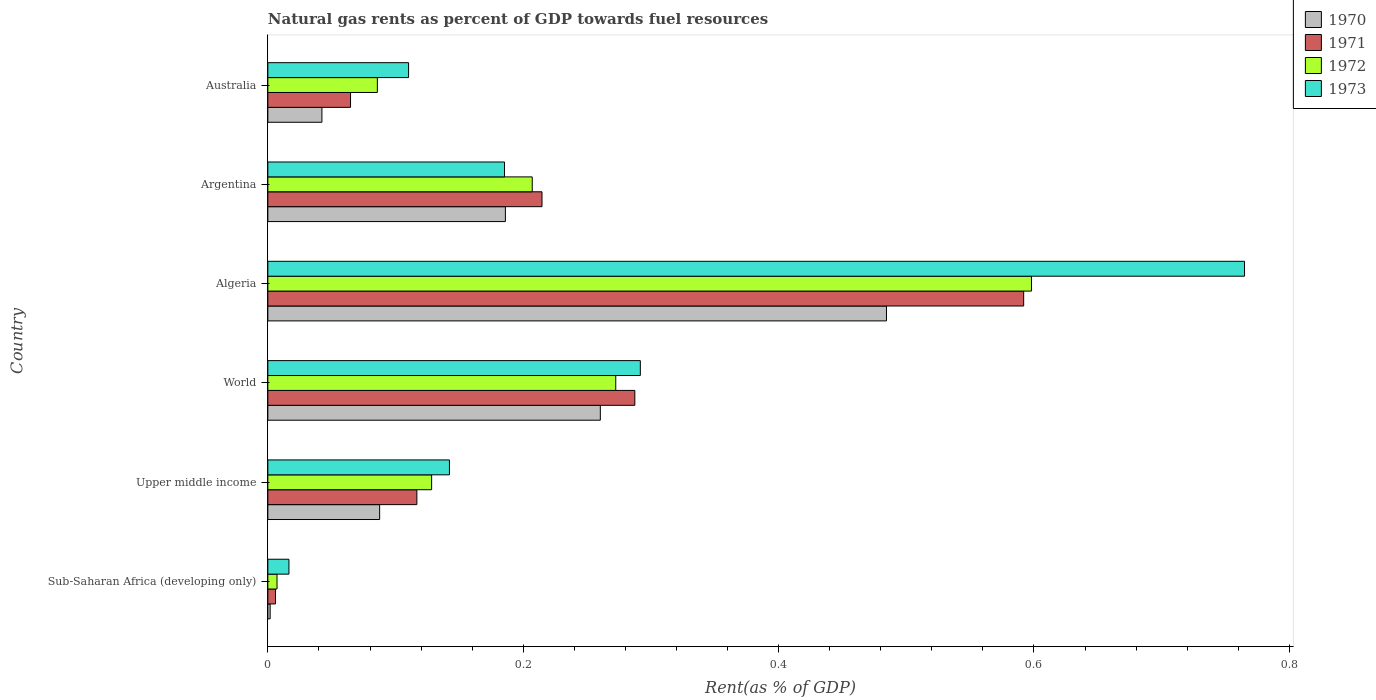How many different coloured bars are there?
Your response must be concise. 4. How many groups of bars are there?
Provide a succinct answer. 6. Are the number of bars per tick equal to the number of legend labels?
Offer a terse response. Yes. What is the label of the 1st group of bars from the top?
Offer a very short reply. Australia. In how many cases, is the number of bars for a given country not equal to the number of legend labels?
Ensure brevity in your answer.  0. What is the matural gas rent in 1973 in World?
Your answer should be compact. 0.29. Across all countries, what is the maximum matural gas rent in 1970?
Ensure brevity in your answer.  0.48. Across all countries, what is the minimum matural gas rent in 1971?
Ensure brevity in your answer.  0.01. In which country was the matural gas rent in 1972 maximum?
Offer a very short reply. Algeria. In which country was the matural gas rent in 1972 minimum?
Offer a terse response. Sub-Saharan Africa (developing only). What is the total matural gas rent in 1973 in the graph?
Your answer should be very brief. 1.51. What is the difference between the matural gas rent in 1973 in Algeria and that in Argentina?
Your answer should be compact. 0.58. What is the difference between the matural gas rent in 1972 in Australia and the matural gas rent in 1970 in Upper middle income?
Offer a very short reply. -0. What is the average matural gas rent in 1972 per country?
Keep it short and to the point. 0.22. What is the difference between the matural gas rent in 1972 and matural gas rent in 1971 in Argentina?
Your response must be concise. -0.01. In how many countries, is the matural gas rent in 1973 greater than 0.4 %?
Your response must be concise. 1. What is the ratio of the matural gas rent in 1970 in Australia to that in Upper middle income?
Your response must be concise. 0.48. Is the matural gas rent in 1973 in Algeria less than that in Australia?
Offer a terse response. No. What is the difference between the highest and the second highest matural gas rent in 1971?
Your answer should be very brief. 0.3. What is the difference between the highest and the lowest matural gas rent in 1970?
Ensure brevity in your answer.  0.48. Is the sum of the matural gas rent in 1970 in Algeria and Upper middle income greater than the maximum matural gas rent in 1971 across all countries?
Give a very brief answer. No. What does the 3rd bar from the bottom in Upper middle income represents?
Your answer should be compact. 1972. Is it the case that in every country, the sum of the matural gas rent in 1970 and matural gas rent in 1971 is greater than the matural gas rent in 1972?
Provide a short and direct response. Yes. Are all the bars in the graph horizontal?
Provide a succinct answer. Yes. How many countries are there in the graph?
Your answer should be compact. 6. Are the values on the major ticks of X-axis written in scientific E-notation?
Your response must be concise. No. Does the graph contain any zero values?
Provide a short and direct response. No. Does the graph contain grids?
Your response must be concise. No. Where does the legend appear in the graph?
Make the answer very short. Top right. How many legend labels are there?
Make the answer very short. 4. What is the title of the graph?
Make the answer very short. Natural gas rents as percent of GDP towards fuel resources. Does "1965" appear as one of the legend labels in the graph?
Your response must be concise. No. What is the label or title of the X-axis?
Offer a terse response. Rent(as % of GDP). What is the label or title of the Y-axis?
Offer a very short reply. Country. What is the Rent(as % of GDP) in 1970 in Sub-Saharan Africa (developing only)?
Make the answer very short. 0. What is the Rent(as % of GDP) in 1971 in Sub-Saharan Africa (developing only)?
Your answer should be very brief. 0.01. What is the Rent(as % of GDP) in 1972 in Sub-Saharan Africa (developing only)?
Offer a very short reply. 0.01. What is the Rent(as % of GDP) in 1973 in Sub-Saharan Africa (developing only)?
Keep it short and to the point. 0.02. What is the Rent(as % of GDP) in 1970 in Upper middle income?
Your response must be concise. 0.09. What is the Rent(as % of GDP) in 1971 in Upper middle income?
Provide a succinct answer. 0.12. What is the Rent(as % of GDP) of 1972 in Upper middle income?
Make the answer very short. 0.13. What is the Rent(as % of GDP) of 1973 in Upper middle income?
Give a very brief answer. 0.14. What is the Rent(as % of GDP) of 1970 in World?
Provide a succinct answer. 0.26. What is the Rent(as % of GDP) in 1971 in World?
Provide a succinct answer. 0.29. What is the Rent(as % of GDP) of 1972 in World?
Provide a succinct answer. 0.27. What is the Rent(as % of GDP) in 1973 in World?
Keep it short and to the point. 0.29. What is the Rent(as % of GDP) of 1970 in Algeria?
Keep it short and to the point. 0.48. What is the Rent(as % of GDP) in 1971 in Algeria?
Your answer should be very brief. 0.59. What is the Rent(as % of GDP) of 1972 in Algeria?
Provide a succinct answer. 0.6. What is the Rent(as % of GDP) of 1973 in Algeria?
Provide a short and direct response. 0.76. What is the Rent(as % of GDP) of 1970 in Argentina?
Offer a terse response. 0.19. What is the Rent(as % of GDP) of 1971 in Argentina?
Offer a very short reply. 0.21. What is the Rent(as % of GDP) in 1972 in Argentina?
Offer a terse response. 0.21. What is the Rent(as % of GDP) of 1973 in Argentina?
Offer a very short reply. 0.19. What is the Rent(as % of GDP) in 1970 in Australia?
Your answer should be compact. 0.04. What is the Rent(as % of GDP) in 1971 in Australia?
Make the answer very short. 0.06. What is the Rent(as % of GDP) in 1972 in Australia?
Offer a very short reply. 0.09. What is the Rent(as % of GDP) in 1973 in Australia?
Provide a succinct answer. 0.11. Across all countries, what is the maximum Rent(as % of GDP) in 1970?
Give a very brief answer. 0.48. Across all countries, what is the maximum Rent(as % of GDP) of 1971?
Provide a succinct answer. 0.59. Across all countries, what is the maximum Rent(as % of GDP) of 1972?
Your response must be concise. 0.6. Across all countries, what is the maximum Rent(as % of GDP) of 1973?
Your answer should be very brief. 0.76. Across all countries, what is the minimum Rent(as % of GDP) in 1970?
Ensure brevity in your answer.  0. Across all countries, what is the minimum Rent(as % of GDP) of 1971?
Keep it short and to the point. 0.01. Across all countries, what is the minimum Rent(as % of GDP) of 1972?
Offer a very short reply. 0.01. Across all countries, what is the minimum Rent(as % of GDP) of 1973?
Your response must be concise. 0.02. What is the total Rent(as % of GDP) in 1970 in the graph?
Your response must be concise. 1.06. What is the total Rent(as % of GDP) of 1971 in the graph?
Make the answer very short. 1.28. What is the total Rent(as % of GDP) in 1972 in the graph?
Offer a very short reply. 1.3. What is the total Rent(as % of GDP) in 1973 in the graph?
Your answer should be compact. 1.51. What is the difference between the Rent(as % of GDP) in 1970 in Sub-Saharan Africa (developing only) and that in Upper middle income?
Provide a succinct answer. -0.09. What is the difference between the Rent(as % of GDP) in 1971 in Sub-Saharan Africa (developing only) and that in Upper middle income?
Provide a succinct answer. -0.11. What is the difference between the Rent(as % of GDP) in 1972 in Sub-Saharan Africa (developing only) and that in Upper middle income?
Provide a succinct answer. -0.12. What is the difference between the Rent(as % of GDP) in 1973 in Sub-Saharan Africa (developing only) and that in Upper middle income?
Provide a succinct answer. -0.13. What is the difference between the Rent(as % of GDP) in 1970 in Sub-Saharan Africa (developing only) and that in World?
Make the answer very short. -0.26. What is the difference between the Rent(as % of GDP) of 1971 in Sub-Saharan Africa (developing only) and that in World?
Your answer should be very brief. -0.28. What is the difference between the Rent(as % of GDP) in 1972 in Sub-Saharan Africa (developing only) and that in World?
Your answer should be compact. -0.27. What is the difference between the Rent(as % of GDP) of 1973 in Sub-Saharan Africa (developing only) and that in World?
Ensure brevity in your answer.  -0.28. What is the difference between the Rent(as % of GDP) in 1970 in Sub-Saharan Africa (developing only) and that in Algeria?
Provide a succinct answer. -0.48. What is the difference between the Rent(as % of GDP) of 1971 in Sub-Saharan Africa (developing only) and that in Algeria?
Offer a very short reply. -0.59. What is the difference between the Rent(as % of GDP) of 1972 in Sub-Saharan Africa (developing only) and that in Algeria?
Your answer should be very brief. -0.59. What is the difference between the Rent(as % of GDP) of 1973 in Sub-Saharan Africa (developing only) and that in Algeria?
Your response must be concise. -0.75. What is the difference between the Rent(as % of GDP) in 1970 in Sub-Saharan Africa (developing only) and that in Argentina?
Give a very brief answer. -0.18. What is the difference between the Rent(as % of GDP) of 1971 in Sub-Saharan Africa (developing only) and that in Argentina?
Offer a terse response. -0.21. What is the difference between the Rent(as % of GDP) of 1972 in Sub-Saharan Africa (developing only) and that in Argentina?
Your answer should be compact. -0.2. What is the difference between the Rent(as % of GDP) of 1973 in Sub-Saharan Africa (developing only) and that in Argentina?
Your answer should be compact. -0.17. What is the difference between the Rent(as % of GDP) in 1970 in Sub-Saharan Africa (developing only) and that in Australia?
Offer a very short reply. -0.04. What is the difference between the Rent(as % of GDP) in 1971 in Sub-Saharan Africa (developing only) and that in Australia?
Ensure brevity in your answer.  -0.06. What is the difference between the Rent(as % of GDP) of 1972 in Sub-Saharan Africa (developing only) and that in Australia?
Your answer should be very brief. -0.08. What is the difference between the Rent(as % of GDP) of 1973 in Sub-Saharan Africa (developing only) and that in Australia?
Keep it short and to the point. -0.09. What is the difference between the Rent(as % of GDP) in 1970 in Upper middle income and that in World?
Provide a short and direct response. -0.17. What is the difference between the Rent(as % of GDP) in 1971 in Upper middle income and that in World?
Provide a short and direct response. -0.17. What is the difference between the Rent(as % of GDP) of 1972 in Upper middle income and that in World?
Keep it short and to the point. -0.14. What is the difference between the Rent(as % of GDP) in 1973 in Upper middle income and that in World?
Your answer should be very brief. -0.15. What is the difference between the Rent(as % of GDP) of 1970 in Upper middle income and that in Algeria?
Ensure brevity in your answer.  -0.4. What is the difference between the Rent(as % of GDP) in 1971 in Upper middle income and that in Algeria?
Offer a terse response. -0.48. What is the difference between the Rent(as % of GDP) of 1972 in Upper middle income and that in Algeria?
Offer a very short reply. -0.47. What is the difference between the Rent(as % of GDP) of 1973 in Upper middle income and that in Algeria?
Keep it short and to the point. -0.62. What is the difference between the Rent(as % of GDP) in 1970 in Upper middle income and that in Argentina?
Ensure brevity in your answer.  -0.1. What is the difference between the Rent(as % of GDP) of 1971 in Upper middle income and that in Argentina?
Keep it short and to the point. -0.1. What is the difference between the Rent(as % of GDP) in 1972 in Upper middle income and that in Argentina?
Your answer should be compact. -0.08. What is the difference between the Rent(as % of GDP) of 1973 in Upper middle income and that in Argentina?
Your answer should be very brief. -0.04. What is the difference between the Rent(as % of GDP) of 1970 in Upper middle income and that in Australia?
Provide a short and direct response. 0.05. What is the difference between the Rent(as % of GDP) of 1971 in Upper middle income and that in Australia?
Offer a very short reply. 0.05. What is the difference between the Rent(as % of GDP) in 1972 in Upper middle income and that in Australia?
Give a very brief answer. 0.04. What is the difference between the Rent(as % of GDP) of 1973 in Upper middle income and that in Australia?
Your answer should be very brief. 0.03. What is the difference between the Rent(as % of GDP) of 1970 in World and that in Algeria?
Provide a succinct answer. -0.22. What is the difference between the Rent(as % of GDP) in 1971 in World and that in Algeria?
Your response must be concise. -0.3. What is the difference between the Rent(as % of GDP) in 1972 in World and that in Algeria?
Keep it short and to the point. -0.33. What is the difference between the Rent(as % of GDP) of 1973 in World and that in Algeria?
Offer a terse response. -0.47. What is the difference between the Rent(as % of GDP) in 1970 in World and that in Argentina?
Your response must be concise. 0.07. What is the difference between the Rent(as % of GDP) in 1971 in World and that in Argentina?
Your answer should be very brief. 0.07. What is the difference between the Rent(as % of GDP) of 1972 in World and that in Argentina?
Offer a very short reply. 0.07. What is the difference between the Rent(as % of GDP) of 1973 in World and that in Argentina?
Your response must be concise. 0.11. What is the difference between the Rent(as % of GDP) of 1970 in World and that in Australia?
Offer a very short reply. 0.22. What is the difference between the Rent(as % of GDP) in 1971 in World and that in Australia?
Provide a succinct answer. 0.22. What is the difference between the Rent(as % of GDP) of 1972 in World and that in Australia?
Your answer should be compact. 0.19. What is the difference between the Rent(as % of GDP) of 1973 in World and that in Australia?
Offer a very short reply. 0.18. What is the difference between the Rent(as % of GDP) of 1970 in Algeria and that in Argentina?
Your answer should be very brief. 0.3. What is the difference between the Rent(as % of GDP) of 1971 in Algeria and that in Argentina?
Keep it short and to the point. 0.38. What is the difference between the Rent(as % of GDP) of 1972 in Algeria and that in Argentina?
Offer a very short reply. 0.39. What is the difference between the Rent(as % of GDP) in 1973 in Algeria and that in Argentina?
Make the answer very short. 0.58. What is the difference between the Rent(as % of GDP) in 1970 in Algeria and that in Australia?
Ensure brevity in your answer.  0.44. What is the difference between the Rent(as % of GDP) of 1971 in Algeria and that in Australia?
Your answer should be compact. 0.53. What is the difference between the Rent(as % of GDP) in 1972 in Algeria and that in Australia?
Provide a short and direct response. 0.51. What is the difference between the Rent(as % of GDP) in 1973 in Algeria and that in Australia?
Provide a succinct answer. 0.65. What is the difference between the Rent(as % of GDP) in 1970 in Argentina and that in Australia?
Offer a terse response. 0.14. What is the difference between the Rent(as % of GDP) in 1971 in Argentina and that in Australia?
Your answer should be compact. 0.15. What is the difference between the Rent(as % of GDP) of 1972 in Argentina and that in Australia?
Keep it short and to the point. 0.12. What is the difference between the Rent(as % of GDP) of 1973 in Argentina and that in Australia?
Keep it short and to the point. 0.08. What is the difference between the Rent(as % of GDP) of 1970 in Sub-Saharan Africa (developing only) and the Rent(as % of GDP) of 1971 in Upper middle income?
Provide a short and direct response. -0.11. What is the difference between the Rent(as % of GDP) in 1970 in Sub-Saharan Africa (developing only) and the Rent(as % of GDP) in 1972 in Upper middle income?
Give a very brief answer. -0.13. What is the difference between the Rent(as % of GDP) in 1970 in Sub-Saharan Africa (developing only) and the Rent(as % of GDP) in 1973 in Upper middle income?
Keep it short and to the point. -0.14. What is the difference between the Rent(as % of GDP) of 1971 in Sub-Saharan Africa (developing only) and the Rent(as % of GDP) of 1972 in Upper middle income?
Ensure brevity in your answer.  -0.12. What is the difference between the Rent(as % of GDP) in 1971 in Sub-Saharan Africa (developing only) and the Rent(as % of GDP) in 1973 in Upper middle income?
Offer a terse response. -0.14. What is the difference between the Rent(as % of GDP) in 1972 in Sub-Saharan Africa (developing only) and the Rent(as % of GDP) in 1973 in Upper middle income?
Ensure brevity in your answer.  -0.14. What is the difference between the Rent(as % of GDP) in 1970 in Sub-Saharan Africa (developing only) and the Rent(as % of GDP) in 1971 in World?
Your answer should be very brief. -0.29. What is the difference between the Rent(as % of GDP) in 1970 in Sub-Saharan Africa (developing only) and the Rent(as % of GDP) in 1972 in World?
Keep it short and to the point. -0.27. What is the difference between the Rent(as % of GDP) of 1970 in Sub-Saharan Africa (developing only) and the Rent(as % of GDP) of 1973 in World?
Ensure brevity in your answer.  -0.29. What is the difference between the Rent(as % of GDP) in 1971 in Sub-Saharan Africa (developing only) and the Rent(as % of GDP) in 1972 in World?
Your response must be concise. -0.27. What is the difference between the Rent(as % of GDP) in 1971 in Sub-Saharan Africa (developing only) and the Rent(as % of GDP) in 1973 in World?
Provide a short and direct response. -0.29. What is the difference between the Rent(as % of GDP) in 1972 in Sub-Saharan Africa (developing only) and the Rent(as % of GDP) in 1973 in World?
Offer a very short reply. -0.28. What is the difference between the Rent(as % of GDP) in 1970 in Sub-Saharan Africa (developing only) and the Rent(as % of GDP) in 1971 in Algeria?
Provide a short and direct response. -0.59. What is the difference between the Rent(as % of GDP) in 1970 in Sub-Saharan Africa (developing only) and the Rent(as % of GDP) in 1972 in Algeria?
Your response must be concise. -0.6. What is the difference between the Rent(as % of GDP) in 1970 in Sub-Saharan Africa (developing only) and the Rent(as % of GDP) in 1973 in Algeria?
Make the answer very short. -0.76. What is the difference between the Rent(as % of GDP) in 1971 in Sub-Saharan Africa (developing only) and the Rent(as % of GDP) in 1972 in Algeria?
Offer a very short reply. -0.59. What is the difference between the Rent(as % of GDP) of 1971 in Sub-Saharan Africa (developing only) and the Rent(as % of GDP) of 1973 in Algeria?
Keep it short and to the point. -0.76. What is the difference between the Rent(as % of GDP) in 1972 in Sub-Saharan Africa (developing only) and the Rent(as % of GDP) in 1973 in Algeria?
Ensure brevity in your answer.  -0.76. What is the difference between the Rent(as % of GDP) of 1970 in Sub-Saharan Africa (developing only) and the Rent(as % of GDP) of 1971 in Argentina?
Keep it short and to the point. -0.21. What is the difference between the Rent(as % of GDP) in 1970 in Sub-Saharan Africa (developing only) and the Rent(as % of GDP) in 1972 in Argentina?
Keep it short and to the point. -0.21. What is the difference between the Rent(as % of GDP) of 1970 in Sub-Saharan Africa (developing only) and the Rent(as % of GDP) of 1973 in Argentina?
Your answer should be very brief. -0.18. What is the difference between the Rent(as % of GDP) of 1971 in Sub-Saharan Africa (developing only) and the Rent(as % of GDP) of 1972 in Argentina?
Ensure brevity in your answer.  -0.2. What is the difference between the Rent(as % of GDP) of 1971 in Sub-Saharan Africa (developing only) and the Rent(as % of GDP) of 1973 in Argentina?
Provide a short and direct response. -0.18. What is the difference between the Rent(as % of GDP) of 1972 in Sub-Saharan Africa (developing only) and the Rent(as % of GDP) of 1973 in Argentina?
Your response must be concise. -0.18. What is the difference between the Rent(as % of GDP) of 1970 in Sub-Saharan Africa (developing only) and the Rent(as % of GDP) of 1971 in Australia?
Give a very brief answer. -0.06. What is the difference between the Rent(as % of GDP) in 1970 in Sub-Saharan Africa (developing only) and the Rent(as % of GDP) in 1972 in Australia?
Your answer should be compact. -0.08. What is the difference between the Rent(as % of GDP) in 1970 in Sub-Saharan Africa (developing only) and the Rent(as % of GDP) in 1973 in Australia?
Offer a terse response. -0.11. What is the difference between the Rent(as % of GDP) in 1971 in Sub-Saharan Africa (developing only) and the Rent(as % of GDP) in 1972 in Australia?
Your response must be concise. -0.08. What is the difference between the Rent(as % of GDP) in 1971 in Sub-Saharan Africa (developing only) and the Rent(as % of GDP) in 1973 in Australia?
Provide a succinct answer. -0.1. What is the difference between the Rent(as % of GDP) of 1972 in Sub-Saharan Africa (developing only) and the Rent(as % of GDP) of 1973 in Australia?
Give a very brief answer. -0.1. What is the difference between the Rent(as % of GDP) in 1970 in Upper middle income and the Rent(as % of GDP) in 1971 in World?
Your answer should be compact. -0.2. What is the difference between the Rent(as % of GDP) of 1970 in Upper middle income and the Rent(as % of GDP) of 1972 in World?
Give a very brief answer. -0.18. What is the difference between the Rent(as % of GDP) of 1970 in Upper middle income and the Rent(as % of GDP) of 1973 in World?
Keep it short and to the point. -0.2. What is the difference between the Rent(as % of GDP) of 1971 in Upper middle income and the Rent(as % of GDP) of 1972 in World?
Make the answer very short. -0.16. What is the difference between the Rent(as % of GDP) in 1971 in Upper middle income and the Rent(as % of GDP) in 1973 in World?
Keep it short and to the point. -0.17. What is the difference between the Rent(as % of GDP) in 1972 in Upper middle income and the Rent(as % of GDP) in 1973 in World?
Your answer should be compact. -0.16. What is the difference between the Rent(as % of GDP) of 1970 in Upper middle income and the Rent(as % of GDP) of 1971 in Algeria?
Offer a very short reply. -0.5. What is the difference between the Rent(as % of GDP) of 1970 in Upper middle income and the Rent(as % of GDP) of 1972 in Algeria?
Provide a succinct answer. -0.51. What is the difference between the Rent(as % of GDP) of 1970 in Upper middle income and the Rent(as % of GDP) of 1973 in Algeria?
Provide a short and direct response. -0.68. What is the difference between the Rent(as % of GDP) in 1971 in Upper middle income and the Rent(as % of GDP) in 1972 in Algeria?
Your answer should be compact. -0.48. What is the difference between the Rent(as % of GDP) in 1971 in Upper middle income and the Rent(as % of GDP) in 1973 in Algeria?
Provide a succinct answer. -0.65. What is the difference between the Rent(as % of GDP) in 1972 in Upper middle income and the Rent(as % of GDP) in 1973 in Algeria?
Keep it short and to the point. -0.64. What is the difference between the Rent(as % of GDP) in 1970 in Upper middle income and the Rent(as % of GDP) in 1971 in Argentina?
Your response must be concise. -0.13. What is the difference between the Rent(as % of GDP) of 1970 in Upper middle income and the Rent(as % of GDP) of 1972 in Argentina?
Provide a succinct answer. -0.12. What is the difference between the Rent(as % of GDP) in 1970 in Upper middle income and the Rent(as % of GDP) in 1973 in Argentina?
Provide a succinct answer. -0.1. What is the difference between the Rent(as % of GDP) of 1971 in Upper middle income and the Rent(as % of GDP) of 1972 in Argentina?
Your response must be concise. -0.09. What is the difference between the Rent(as % of GDP) in 1971 in Upper middle income and the Rent(as % of GDP) in 1973 in Argentina?
Provide a succinct answer. -0.07. What is the difference between the Rent(as % of GDP) in 1972 in Upper middle income and the Rent(as % of GDP) in 1973 in Argentina?
Offer a terse response. -0.06. What is the difference between the Rent(as % of GDP) of 1970 in Upper middle income and the Rent(as % of GDP) of 1971 in Australia?
Make the answer very short. 0.02. What is the difference between the Rent(as % of GDP) in 1970 in Upper middle income and the Rent(as % of GDP) in 1972 in Australia?
Ensure brevity in your answer.  0. What is the difference between the Rent(as % of GDP) of 1970 in Upper middle income and the Rent(as % of GDP) of 1973 in Australia?
Offer a terse response. -0.02. What is the difference between the Rent(as % of GDP) in 1971 in Upper middle income and the Rent(as % of GDP) in 1972 in Australia?
Your answer should be compact. 0.03. What is the difference between the Rent(as % of GDP) in 1971 in Upper middle income and the Rent(as % of GDP) in 1973 in Australia?
Provide a short and direct response. 0.01. What is the difference between the Rent(as % of GDP) of 1972 in Upper middle income and the Rent(as % of GDP) of 1973 in Australia?
Provide a short and direct response. 0.02. What is the difference between the Rent(as % of GDP) of 1970 in World and the Rent(as % of GDP) of 1971 in Algeria?
Provide a short and direct response. -0.33. What is the difference between the Rent(as % of GDP) of 1970 in World and the Rent(as % of GDP) of 1972 in Algeria?
Provide a short and direct response. -0.34. What is the difference between the Rent(as % of GDP) of 1970 in World and the Rent(as % of GDP) of 1973 in Algeria?
Your answer should be very brief. -0.5. What is the difference between the Rent(as % of GDP) of 1971 in World and the Rent(as % of GDP) of 1972 in Algeria?
Your answer should be compact. -0.31. What is the difference between the Rent(as % of GDP) of 1971 in World and the Rent(as % of GDP) of 1973 in Algeria?
Your response must be concise. -0.48. What is the difference between the Rent(as % of GDP) of 1972 in World and the Rent(as % of GDP) of 1973 in Algeria?
Provide a succinct answer. -0.49. What is the difference between the Rent(as % of GDP) in 1970 in World and the Rent(as % of GDP) in 1971 in Argentina?
Offer a terse response. 0.05. What is the difference between the Rent(as % of GDP) in 1970 in World and the Rent(as % of GDP) in 1972 in Argentina?
Provide a succinct answer. 0.05. What is the difference between the Rent(as % of GDP) in 1970 in World and the Rent(as % of GDP) in 1973 in Argentina?
Give a very brief answer. 0.07. What is the difference between the Rent(as % of GDP) in 1971 in World and the Rent(as % of GDP) in 1972 in Argentina?
Your answer should be compact. 0.08. What is the difference between the Rent(as % of GDP) in 1971 in World and the Rent(as % of GDP) in 1973 in Argentina?
Your answer should be very brief. 0.1. What is the difference between the Rent(as % of GDP) of 1972 in World and the Rent(as % of GDP) of 1973 in Argentina?
Your response must be concise. 0.09. What is the difference between the Rent(as % of GDP) in 1970 in World and the Rent(as % of GDP) in 1971 in Australia?
Offer a very short reply. 0.2. What is the difference between the Rent(as % of GDP) of 1970 in World and the Rent(as % of GDP) of 1972 in Australia?
Your response must be concise. 0.17. What is the difference between the Rent(as % of GDP) of 1970 in World and the Rent(as % of GDP) of 1973 in Australia?
Give a very brief answer. 0.15. What is the difference between the Rent(as % of GDP) of 1971 in World and the Rent(as % of GDP) of 1972 in Australia?
Your answer should be compact. 0.2. What is the difference between the Rent(as % of GDP) in 1971 in World and the Rent(as % of GDP) in 1973 in Australia?
Offer a terse response. 0.18. What is the difference between the Rent(as % of GDP) of 1972 in World and the Rent(as % of GDP) of 1973 in Australia?
Make the answer very short. 0.16. What is the difference between the Rent(as % of GDP) in 1970 in Algeria and the Rent(as % of GDP) in 1971 in Argentina?
Keep it short and to the point. 0.27. What is the difference between the Rent(as % of GDP) of 1970 in Algeria and the Rent(as % of GDP) of 1972 in Argentina?
Your answer should be compact. 0.28. What is the difference between the Rent(as % of GDP) of 1970 in Algeria and the Rent(as % of GDP) of 1973 in Argentina?
Your answer should be very brief. 0.3. What is the difference between the Rent(as % of GDP) in 1971 in Algeria and the Rent(as % of GDP) in 1972 in Argentina?
Keep it short and to the point. 0.38. What is the difference between the Rent(as % of GDP) in 1971 in Algeria and the Rent(as % of GDP) in 1973 in Argentina?
Keep it short and to the point. 0.41. What is the difference between the Rent(as % of GDP) in 1972 in Algeria and the Rent(as % of GDP) in 1973 in Argentina?
Your answer should be very brief. 0.41. What is the difference between the Rent(as % of GDP) of 1970 in Algeria and the Rent(as % of GDP) of 1971 in Australia?
Offer a very short reply. 0.42. What is the difference between the Rent(as % of GDP) of 1970 in Algeria and the Rent(as % of GDP) of 1972 in Australia?
Provide a succinct answer. 0.4. What is the difference between the Rent(as % of GDP) in 1970 in Algeria and the Rent(as % of GDP) in 1973 in Australia?
Your answer should be compact. 0.37. What is the difference between the Rent(as % of GDP) in 1971 in Algeria and the Rent(as % of GDP) in 1972 in Australia?
Keep it short and to the point. 0.51. What is the difference between the Rent(as % of GDP) in 1971 in Algeria and the Rent(as % of GDP) in 1973 in Australia?
Offer a terse response. 0.48. What is the difference between the Rent(as % of GDP) of 1972 in Algeria and the Rent(as % of GDP) of 1973 in Australia?
Offer a very short reply. 0.49. What is the difference between the Rent(as % of GDP) of 1970 in Argentina and the Rent(as % of GDP) of 1971 in Australia?
Your answer should be compact. 0.12. What is the difference between the Rent(as % of GDP) of 1970 in Argentina and the Rent(as % of GDP) of 1972 in Australia?
Give a very brief answer. 0.1. What is the difference between the Rent(as % of GDP) in 1970 in Argentina and the Rent(as % of GDP) in 1973 in Australia?
Your answer should be very brief. 0.08. What is the difference between the Rent(as % of GDP) in 1971 in Argentina and the Rent(as % of GDP) in 1972 in Australia?
Keep it short and to the point. 0.13. What is the difference between the Rent(as % of GDP) in 1971 in Argentina and the Rent(as % of GDP) in 1973 in Australia?
Keep it short and to the point. 0.1. What is the difference between the Rent(as % of GDP) of 1972 in Argentina and the Rent(as % of GDP) of 1973 in Australia?
Offer a very short reply. 0.1. What is the average Rent(as % of GDP) in 1970 per country?
Your answer should be compact. 0.18. What is the average Rent(as % of GDP) of 1971 per country?
Provide a succinct answer. 0.21. What is the average Rent(as % of GDP) of 1972 per country?
Offer a very short reply. 0.22. What is the average Rent(as % of GDP) of 1973 per country?
Ensure brevity in your answer.  0.25. What is the difference between the Rent(as % of GDP) in 1970 and Rent(as % of GDP) in 1971 in Sub-Saharan Africa (developing only)?
Make the answer very short. -0. What is the difference between the Rent(as % of GDP) of 1970 and Rent(as % of GDP) of 1972 in Sub-Saharan Africa (developing only)?
Offer a terse response. -0.01. What is the difference between the Rent(as % of GDP) in 1970 and Rent(as % of GDP) in 1973 in Sub-Saharan Africa (developing only)?
Provide a succinct answer. -0.01. What is the difference between the Rent(as % of GDP) in 1971 and Rent(as % of GDP) in 1972 in Sub-Saharan Africa (developing only)?
Your answer should be very brief. -0. What is the difference between the Rent(as % of GDP) of 1971 and Rent(as % of GDP) of 1973 in Sub-Saharan Africa (developing only)?
Offer a very short reply. -0.01. What is the difference between the Rent(as % of GDP) of 1972 and Rent(as % of GDP) of 1973 in Sub-Saharan Africa (developing only)?
Your answer should be very brief. -0.01. What is the difference between the Rent(as % of GDP) of 1970 and Rent(as % of GDP) of 1971 in Upper middle income?
Offer a very short reply. -0.03. What is the difference between the Rent(as % of GDP) in 1970 and Rent(as % of GDP) in 1972 in Upper middle income?
Offer a terse response. -0.04. What is the difference between the Rent(as % of GDP) in 1970 and Rent(as % of GDP) in 1973 in Upper middle income?
Keep it short and to the point. -0.05. What is the difference between the Rent(as % of GDP) in 1971 and Rent(as % of GDP) in 1972 in Upper middle income?
Make the answer very short. -0.01. What is the difference between the Rent(as % of GDP) in 1971 and Rent(as % of GDP) in 1973 in Upper middle income?
Provide a succinct answer. -0.03. What is the difference between the Rent(as % of GDP) of 1972 and Rent(as % of GDP) of 1973 in Upper middle income?
Make the answer very short. -0.01. What is the difference between the Rent(as % of GDP) of 1970 and Rent(as % of GDP) of 1971 in World?
Offer a very short reply. -0.03. What is the difference between the Rent(as % of GDP) of 1970 and Rent(as % of GDP) of 1972 in World?
Provide a short and direct response. -0.01. What is the difference between the Rent(as % of GDP) in 1970 and Rent(as % of GDP) in 1973 in World?
Keep it short and to the point. -0.03. What is the difference between the Rent(as % of GDP) of 1971 and Rent(as % of GDP) of 1972 in World?
Provide a short and direct response. 0.01. What is the difference between the Rent(as % of GDP) of 1971 and Rent(as % of GDP) of 1973 in World?
Ensure brevity in your answer.  -0. What is the difference between the Rent(as % of GDP) in 1972 and Rent(as % of GDP) in 1973 in World?
Keep it short and to the point. -0.02. What is the difference between the Rent(as % of GDP) of 1970 and Rent(as % of GDP) of 1971 in Algeria?
Make the answer very short. -0.11. What is the difference between the Rent(as % of GDP) in 1970 and Rent(as % of GDP) in 1972 in Algeria?
Make the answer very short. -0.11. What is the difference between the Rent(as % of GDP) of 1970 and Rent(as % of GDP) of 1973 in Algeria?
Keep it short and to the point. -0.28. What is the difference between the Rent(as % of GDP) in 1971 and Rent(as % of GDP) in 1972 in Algeria?
Ensure brevity in your answer.  -0.01. What is the difference between the Rent(as % of GDP) of 1971 and Rent(as % of GDP) of 1973 in Algeria?
Keep it short and to the point. -0.17. What is the difference between the Rent(as % of GDP) of 1972 and Rent(as % of GDP) of 1973 in Algeria?
Make the answer very short. -0.17. What is the difference between the Rent(as % of GDP) of 1970 and Rent(as % of GDP) of 1971 in Argentina?
Keep it short and to the point. -0.03. What is the difference between the Rent(as % of GDP) of 1970 and Rent(as % of GDP) of 1972 in Argentina?
Your answer should be compact. -0.02. What is the difference between the Rent(as % of GDP) in 1970 and Rent(as % of GDP) in 1973 in Argentina?
Make the answer very short. 0. What is the difference between the Rent(as % of GDP) of 1971 and Rent(as % of GDP) of 1972 in Argentina?
Offer a very short reply. 0.01. What is the difference between the Rent(as % of GDP) in 1971 and Rent(as % of GDP) in 1973 in Argentina?
Your answer should be compact. 0.03. What is the difference between the Rent(as % of GDP) of 1972 and Rent(as % of GDP) of 1973 in Argentina?
Make the answer very short. 0.02. What is the difference between the Rent(as % of GDP) of 1970 and Rent(as % of GDP) of 1971 in Australia?
Provide a short and direct response. -0.02. What is the difference between the Rent(as % of GDP) of 1970 and Rent(as % of GDP) of 1972 in Australia?
Offer a terse response. -0.04. What is the difference between the Rent(as % of GDP) in 1970 and Rent(as % of GDP) in 1973 in Australia?
Your response must be concise. -0.07. What is the difference between the Rent(as % of GDP) in 1971 and Rent(as % of GDP) in 1972 in Australia?
Make the answer very short. -0.02. What is the difference between the Rent(as % of GDP) of 1971 and Rent(as % of GDP) of 1973 in Australia?
Offer a terse response. -0.05. What is the difference between the Rent(as % of GDP) of 1972 and Rent(as % of GDP) of 1973 in Australia?
Your answer should be very brief. -0.02. What is the ratio of the Rent(as % of GDP) of 1970 in Sub-Saharan Africa (developing only) to that in Upper middle income?
Your answer should be very brief. 0.02. What is the ratio of the Rent(as % of GDP) of 1971 in Sub-Saharan Africa (developing only) to that in Upper middle income?
Provide a succinct answer. 0.05. What is the ratio of the Rent(as % of GDP) of 1972 in Sub-Saharan Africa (developing only) to that in Upper middle income?
Offer a terse response. 0.06. What is the ratio of the Rent(as % of GDP) of 1973 in Sub-Saharan Africa (developing only) to that in Upper middle income?
Your answer should be compact. 0.12. What is the ratio of the Rent(as % of GDP) of 1970 in Sub-Saharan Africa (developing only) to that in World?
Give a very brief answer. 0.01. What is the ratio of the Rent(as % of GDP) of 1971 in Sub-Saharan Africa (developing only) to that in World?
Give a very brief answer. 0.02. What is the ratio of the Rent(as % of GDP) of 1972 in Sub-Saharan Africa (developing only) to that in World?
Provide a short and direct response. 0.03. What is the ratio of the Rent(as % of GDP) of 1973 in Sub-Saharan Africa (developing only) to that in World?
Your answer should be compact. 0.06. What is the ratio of the Rent(as % of GDP) of 1970 in Sub-Saharan Africa (developing only) to that in Algeria?
Make the answer very short. 0. What is the ratio of the Rent(as % of GDP) in 1971 in Sub-Saharan Africa (developing only) to that in Algeria?
Your answer should be very brief. 0.01. What is the ratio of the Rent(as % of GDP) in 1972 in Sub-Saharan Africa (developing only) to that in Algeria?
Make the answer very short. 0.01. What is the ratio of the Rent(as % of GDP) in 1973 in Sub-Saharan Africa (developing only) to that in Algeria?
Your answer should be compact. 0.02. What is the ratio of the Rent(as % of GDP) in 1970 in Sub-Saharan Africa (developing only) to that in Argentina?
Provide a short and direct response. 0.01. What is the ratio of the Rent(as % of GDP) of 1971 in Sub-Saharan Africa (developing only) to that in Argentina?
Offer a very short reply. 0.03. What is the ratio of the Rent(as % of GDP) in 1972 in Sub-Saharan Africa (developing only) to that in Argentina?
Ensure brevity in your answer.  0.03. What is the ratio of the Rent(as % of GDP) of 1973 in Sub-Saharan Africa (developing only) to that in Argentina?
Your response must be concise. 0.09. What is the ratio of the Rent(as % of GDP) in 1970 in Sub-Saharan Africa (developing only) to that in Australia?
Your answer should be compact. 0.04. What is the ratio of the Rent(as % of GDP) in 1971 in Sub-Saharan Africa (developing only) to that in Australia?
Your response must be concise. 0.09. What is the ratio of the Rent(as % of GDP) in 1972 in Sub-Saharan Africa (developing only) to that in Australia?
Your answer should be very brief. 0.08. What is the ratio of the Rent(as % of GDP) in 1973 in Sub-Saharan Africa (developing only) to that in Australia?
Make the answer very short. 0.15. What is the ratio of the Rent(as % of GDP) in 1970 in Upper middle income to that in World?
Offer a terse response. 0.34. What is the ratio of the Rent(as % of GDP) in 1971 in Upper middle income to that in World?
Provide a succinct answer. 0.41. What is the ratio of the Rent(as % of GDP) of 1972 in Upper middle income to that in World?
Offer a terse response. 0.47. What is the ratio of the Rent(as % of GDP) in 1973 in Upper middle income to that in World?
Provide a short and direct response. 0.49. What is the ratio of the Rent(as % of GDP) of 1970 in Upper middle income to that in Algeria?
Provide a short and direct response. 0.18. What is the ratio of the Rent(as % of GDP) in 1971 in Upper middle income to that in Algeria?
Give a very brief answer. 0.2. What is the ratio of the Rent(as % of GDP) of 1972 in Upper middle income to that in Algeria?
Offer a very short reply. 0.21. What is the ratio of the Rent(as % of GDP) in 1973 in Upper middle income to that in Algeria?
Ensure brevity in your answer.  0.19. What is the ratio of the Rent(as % of GDP) of 1970 in Upper middle income to that in Argentina?
Provide a short and direct response. 0.47. What is the ratio of the Rent(as % of GDP) of 1971 in Upper middle income to that in Argentina?
Keep it short and to the point. 0.54. What is the ratio of the Rent(as % of GDP) in 1972 in Upper middle income to that in Argentina?
Your response must be concise. 0.62. What is the ratio of the Rent(as % of GDP) of 1973 in Upper middle income to that in Argentina?
Your answer should be compact. 0.77. What is the ratio of the Rent(as % of GDP) in 1970 in Upper middle income to that in Australia?
Make the answer very short. 2.07. What is the ratio of the Rent(as % of GDP) of 1971 in Upper middle income to that in Australia?
Your answer should be very brief. 1.8. What is the ratio of the Rent(as % of GDP) in 1972 in Upper middle income to that in Australia?
Make the answer very short. 1.5. What is the ratio of the Rent(as % of GDP) in 1973 in Upper middle income to that in Australia?
Offer a very short reply. 1.29. What is the ratio of the Rent(as % of GDP) in 1970 in World to that in Algeria?
Provide a succinct answer. 0.54. What is the ratio of the Rent(as % of GDP) of 1971 in World to that in Algeria?
Your response must be concise. 0.49. What is the ratio of the Rent(as % of GDP) of 1972 in World to that in Algeria?
Provide a succinct answer. 0.46. What is the ratio of the Rent(as % of GDP) of 1973 in World to that in Algeria?
Offer a very short reply. 0.38. What is the ratio of the Rent(as % of GDP) of 1970 in World to that in Argentina?
Offer a terse response. 1.4. What is the ratio of the Rent(as % of GDP) of 1971 in World to that in Argentina?
Give a very brief answer. 1.34. What is the ratio of the Rent(as % of GDP) of 1972 in World to that in Argentina?
Give a very brief answer. 1.32. What is the ratio of the Rent(as % of GDP) in 1973 in World to that in Argentina?
Keep it short and to the point. 1.57. What is the ratio of the Rent(as % of GDP) in 1970 in World to that in Australia?
Provide a succinct answer. 6.15. What is the ratio of the Rent(as % of GDP) of 1971 in World to that in Australia?
Offer a very short reply. 4.44. What is the ratio of the Rent(as % of GDP) in 1972 in World to that in Australia?
Your response must be concise. 3.18. What is the ratio of the Rent(as % of GDP) of 1973 in World to that in Australia?
Your answer should be very brief. 2.65. What is the ratio of the Rent(as % of GDP) of 1970 in Algeria to that in Argentina?
Ensure brevity in your answer.  2.6. What is the ratio of the Rent(as % of GDP) in 1971 in Algeria to that in Argentina?
Make the answer very short. 2.76. What is the ratio of the Rent(as % of GDP) of 1972 in Algeria to that in Argentina?
Your answer should be compact. 2.89. What is the ratio of the Rent(as % of GDP) of 1973 in Algeria to that in Argentina?
Your answer should be compact. 4.13. What is the ratio of the Rent(as % of GDP) in 1970 in Algeria to that in Australia?
Keep it short and to the point. 11.44. What is the ratio of the Rent(as % of GDP) in 1971 in Algeria to that in Australia?
Give a very brief answer. 9.14. What is the ratio of the Rent(as % of GDP) of 1972 in Algeria to that in Australia?
Your answer should be compact. 6.97. What is the ratio of the Rent(as % of GDP) in 1973 in Algeria to that in Australia?
Keep it short and to the point. 6.94. What is the ratio of the Rent(as % of GDP) in 1970 in Argentina to that in Australia?
Make the answer very short. 4.39. What is the ratio of the Rent(as % of GDP) in 1971 in Argentina to that in Australia?
Give a very brief answer. 3.32. What is the ratio of the Rent(as % of GDP) in 1972 in Argentina to that in Australia?
Your response must be concise. 2.41. What is the ratio of the Rent(as % of GDP) in 1973 in Argentina to that in Australia?
Ensure brevity in your answer.  1.68. What is the difference between the highest and the second highest Rent(as % of GDP) of 1970?
Provide a succinct answer. 0.22. What is the difference between the highest and the second highest Rent(as % of GDP) of 1971?
Keep it short and to the point. 0.3. What is the difference between the highest and the second highest Rent(as % of GDP) in 1972?
Your response must be concise. 0.33. What is the difference between the highest and the second highest Rent(as % of GDP) of 1973?
Offer a terse response. 0.47. What is the difference between the highest and the lowest Rent(as % of GDP) in 1970?
Provide a succinct answer. 0.48. What is the difference between the highest and the lowest Rent(as % of GDP) in 1971?
Give a very brief answer. 0.59. What is the difference between the highest and the lowest Rent(as % of GDP) of 1972?
Offer a terse response. 0.59. What is the difference between the highest and the lowest Rent(as % of GDP) in 1973?
Give a very brief answer. 0.75. 